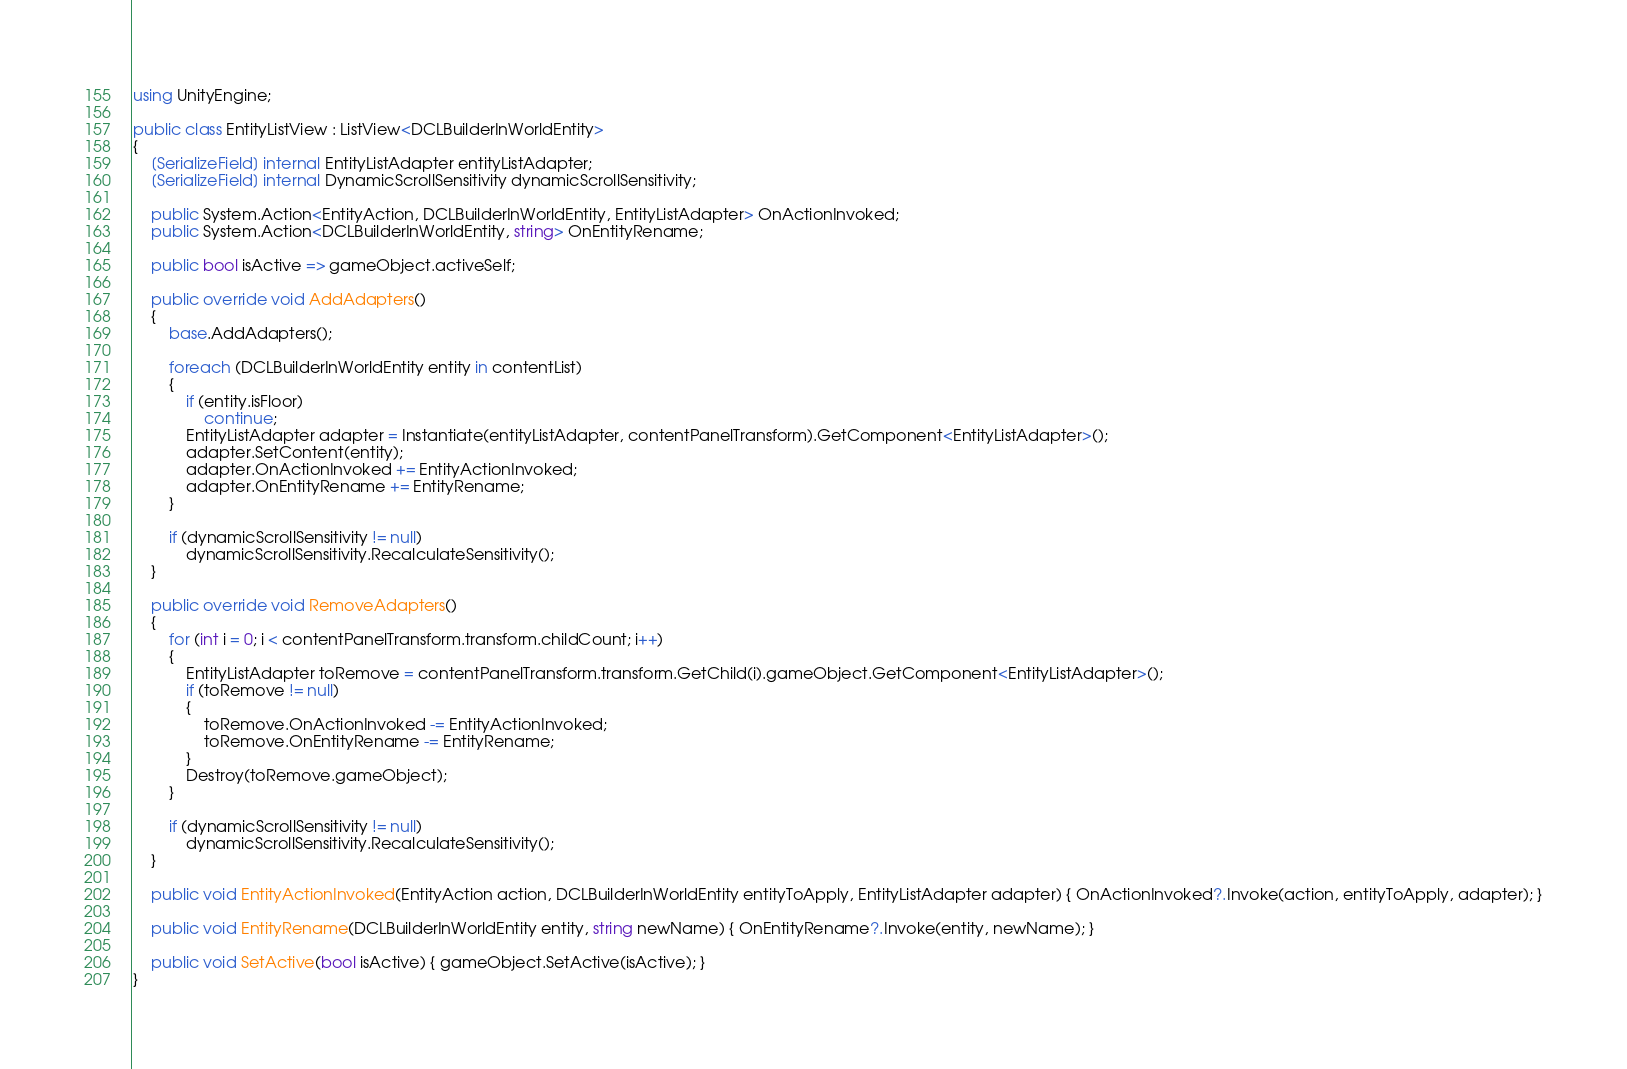Convert code to text. <code><loc_0><loc_0><loc_500><loc_500><_C#_>using UnityEngine;

public class EntityListView : ListView<DCLBuilderInWorldEntity>
{
    [SerializeField] internal EntityListAdapter entityListAdapter;
    [SerializeField] internal DynamicScrollSensitivity dynamicScrollSensitivity;

    public System.Action<EntityAction, DCLBuilderInWorldEntity, EntityListAdapter> OnActionInvoked;
    public System.Action<DCLBuilderInWorldEntity, string> OnEntityRename;

    public bool isActive => gameObject.activeSelf;

    public override void AddAdapters()
    {
        base.AddAdapters();

        foreach (DCLBuilderInWorldEntity entity in contentList)
        {
            if (entity.isFloor)
                continue;
            EntityListAdapter adapter = Instantiate(entityListAdapter, contentPanelTransform).GetComponent<EntityListAdapter>();
            adapter.SetContent(entity);
            adapter.OnActionInvoked += EntityActionInvoked;
            adapter.OnEntityRename += EntityRename;
        }

        if (dynamicScrollSensitivity != null)
            dynamicScrollSensitivity.RecalculateSensitivity();
    }

    public override void RemoveAdapters()
    {
        for (int i = 0; i < contentPanelTransform.transform.childCount; i++)
        {
            EntityListAdapter toRemove = contentPanelTransform.transform.GetChild(i).gameObject.GetComponent<EntityListAdapter>();
            if (toRemove != null)
            {
                toRemove.OnActionInvoked -= EntityActionInvoked;
                toRemove.OnEntityRename -= EntityRename;
            }
            Destroy(toRemove.gameObject);
        }

        if (dynamicScrollSensitivity != null)
            dynamicScrollSensitivity.RecalculateSensitivity();
    }

    public void EntityActionInvoked(EntityAction action, DCLBuilderInWorldEntity entityToApply, EntityListAdapter adapter) { OnActionInvoked?.Invoke(action, entityToApply, adapter); }

    public void EntityRename(DCLBuilderInWorldEntity entity, string newName) { OnEntityRename?.Invoke(entity, newName); }

    public void SetActive(bool isActive) { gameObject.SetActive(isActive); }
}</code> 